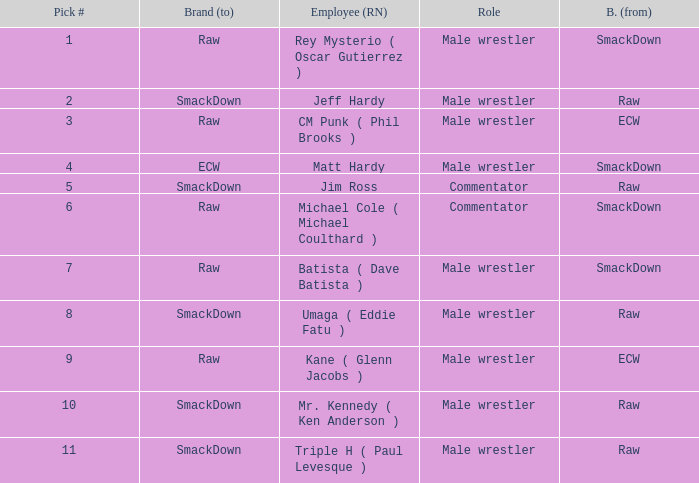Can you give me this table as a dict? {'header': ['Pick #', 'Brand (to)', 'Employee (RN)', 'Role', 'B. (from)'], 'rows': [['1', 'Raw', 'Rey Mysterio ( Oscar Gutierrez )', 'Male wrestler', 'SmackDown'], ['2', 'SmackDown', 'Jeff Hardy', 'Male wrestler', 'Raw'], ['3', 'Raw', 'CM Punk ( Phil Brooks )', 'Male wrestler', 'ECW'], ['4', 'ECW', 'Matt Hardy', 'Male wrestler', 'SmackDown'], ['5', 'SmackDown', 'Jim Ross', 'Commentator', 'Raw'], ['6', 'Raw', 'Michael Cole ( Michael Coulthard )', 'Commentator', 'SmackDown'], ['7', 'Raw', 'Batista ( Dave Batista )', 'Male wrestler', 'SmackDown'], ['8', 'SmackDown', 'Umaga ( Eddie Fatu )', 'Male wrestler', 'Raw'], ['9', 'Raw', 'Kane ( Glenn Jacobs )', 'Male wrestler', 'ECW'], ['10', 'SmackDown', 'Mr. Kennedy ( Ken Anderson )', 'Male wrestler', 'Raw'], ['11', 'SmackDown', 'Triple H ( Paul Levesque )', 'Male wrestler', 'Raw']]} What is the real name of the male wrestler from Raw with a pick # smaller than 6? Jeff Hardy. 